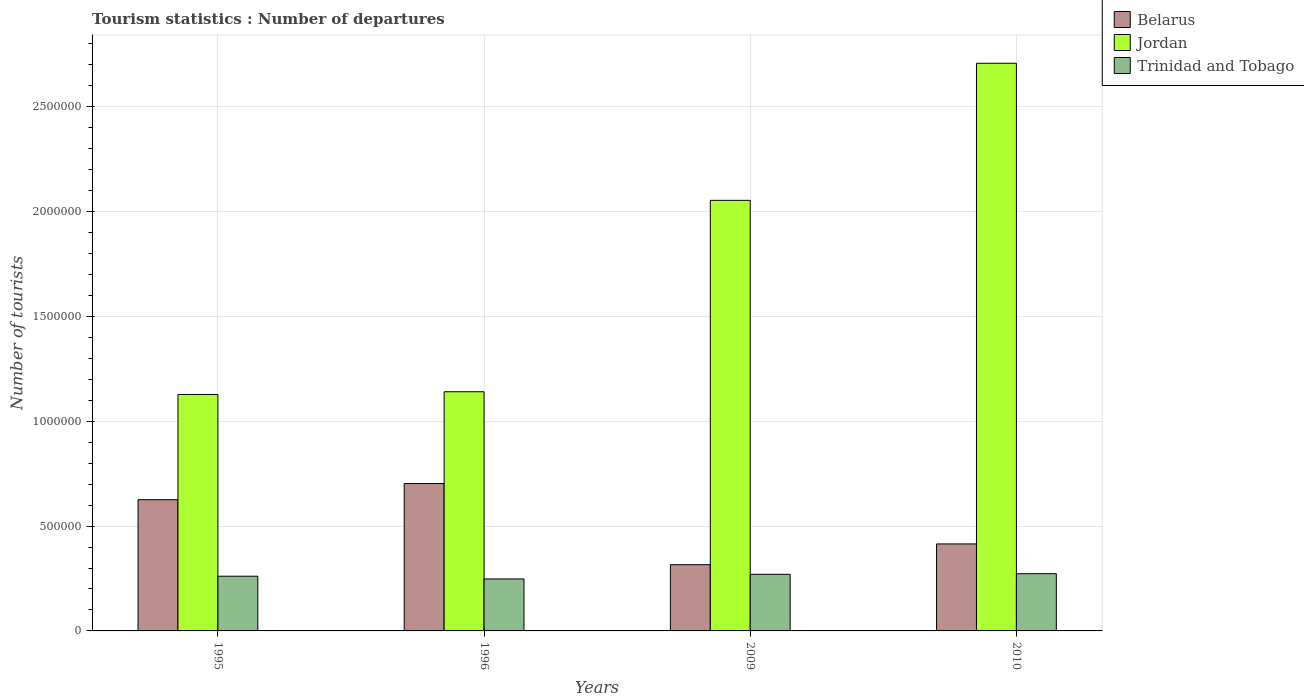Are the number of bars per tick equal to the number of legend labels?
Make the answer very short. Yes. Are the number of bars on each tick of the X-axis equal?
Provide a short and direct response. Yes. What is the number of tourist departures in Jordan in 1995?
Offer a terse response. 1.13e+06. Across all years, what is the maximum number of tourist departures in Belarus?
Your response must be concise. 7.03e+05. Across all years, what is the minimum number of tourist departures in Belarus?
Offer a very short reply. 3.16e+05. In which year was the number of tourist departures in Trinidad and Tobago maximum?
Provide a succinct answer. 2010. What is the total number of tourist departures in Trinidad and Tobago in the graph?
Your answer should be compact. 1.05e+06. What is the difference between the number of tourist departures in Belarus in 1996 and that in 2009?
Your answer should be compact. 3.87e+05. What is the difference between the number of tourist departures in Belarus in 2010 and the number of tourist departures in Jordan in 1995?
Provide a short and direct response. -7.13e+05. What is the average number of tourist departures in Trinidad and Tobago per year?
Your answer should be compact. 2.63e+05. In the year 2009, what is the difference between the number of tourist departures in Trinidad and Tobago and number of tourist departures in Jordan?
Your answer should be compact. -1.78e+06. What is the ratio of the number of tourist departures in Belarus in 1995 to that in 2010?
Ensure brevity in your answer.  1.51. Is the number of tourist departures in Jordan in 1996 less than that in 2009?
Your answer should be compact. Yes. What is the difference between the highest and the second highest number of tourist departures in Belarus?
Your answer should be very brief. 7.70e+04. What is the difference between the highest and the lowest number of tourist departures in Jordan?
Your answer should be compact. 1.58e+06. What does the 1st bar from the left in 1995 represents?
Offer a terse response. Belarus. What does the 3rd bar from the right in 2010 represents?
Provide a short and direct response. Belarus. Are all the bars in the graph horizontal?
Give a very brief answer. No. Does the graph contain any zero values?
Offer a terse response. No. Where does the legend appear in the graph?
Keep it short and to the point. Top right. How many legend labels are there?
Offer a terse response. 3. How are the legend labels stacked?
Provide a short and direct response. Vertical. What is the title of the graph?
Give a very brief answer. Tourism statistics : Number of departures. Does "American Samoa" appear as one of the legend labels in the graph?
Your answer should be compact. No. What is the label or title of the Y-axis?
Your answer should be compact. Number of tourists. What is the Number of tourists in Belarus in 1995?
Offer a terse response. 6.26e+05. What is the Number of tourists of Jordan in 1995?
Make the answer very short. 1.13e+06. What is the Number of tourists of Trinidad and Tobago in 1995?
Provide a short and direct response. 2.61e+05. What is the Number of tourists in Belarus in 1996?
Provide a succinct answer. 7.03e+05. What is the Number of tourists of Jordan in 1996?
Make the answer very short. 1.14e+06. What is the Number of tourists in Trinidad and Tobago in 1996?
Ensure brevity in your answer.  2.48e+05. What is the Number of tourists in Belarus in 2009?
Your response must be concise. 3.16e+05. What is the Number of tourists in Jordan in 2009?
Your response must be concise. 2.05e+06. What is the Number of tourists of Belarus in 2010?
Your answer should be very brief. 4.15e+05. What is the Number of tourists of Jordan in 2010?
Offer a terse response. 2.71e+06. What is the Number of tourists of Trinidad and Tobago in 2010?
Your answer should be compact. 2.73e+05. Across all years, what is the maximum Number of tourists in Belarus?
Ensure brevity in your answer.  7.03e+05. Across all years, what is the maximum Number of tourists of Jordan?
Your answer should be compact. 2.71e+06. Across all years, what is the maximum Number of tourists of Trinidad and Tobago?
Keep it short and to the point. 2.73e+05. Across all years, what is the minimum Number of tourists of Belarus?
Provide a succinct answer. 3.16e+05. Across all years, what is the minimum Number of tourists of Jordan?
Make the answer very short. 1.13e+06. Across all years, what is the minimum Number of tourists in Trinidad and Tobago?
Provide a short and direct response. 2.48e+05. What is the total Number of tourists of Belarus in the graph?
Provide a short and direct response. 2.06e+06. What is the total Number of tourists in Jordan in the graph?
Ensure brevity in your answer.  7.03e+06. What is the total Number of tourists in Trinidad and Tobago in the graph?
Offer a very short reply. 1.05e+06. What is the difference between the Number of tourists in Belarus in 1995 and that in 1996?
Offer a terse response. -7.70e+04. What is the difference between the Number of tourists of Jordan in 1995 and that in 1996?
Keep it short and to the point. -1.30e+04. What is the difference between the Number of tourists in Trinidad and Tobago in 1995 and that in 1996?
Offer a very short reply. 1.30e+04. What is the difference between the Number of tourists of Belarus in 1995 and that in 2009?
Your response must be concise. 3.10e+05. What is the difference between the Number of tourists in Jordan in 1995 and that in 2009?
Your answer should be very brief. -9.26e+05. What is the difference between the Number of tourists of Trinidad and Tobago in 1995 and that in 2009?
Offer a terse response. -9000. What is the difference between the Number of tourists in Belarus in 1995 and that in 2010?
Your response must be concise. 2.11e+05. What is the difference between the Number of tourists of Jordan in 1995 and that in 2010?
Give a very brief answer. -1.58e+06. What is the difference between the Number of tourists of Trinidad and Tobago in 1995 and that in 2010?
Make the answer very short. -1.20e+04. What is the difference between the Number of tourists in Belarus in 1996 and that in 2009?
Your response must be concise. 3.87e+05. What is the difference between the Number of tourists of Jordan in 1996 and that in 2009?
Your response must be concise. -9.13e+05. What is the difference between the Number of tourists in Trinidad and Tobago in 1996 and that in 2009?
Offer a terse response. -2.20e+04. What is the difference between the Number of tourists in Belarus in 1996 and that in 2010?
Your response must be concise. 2.88e+05. What is the difference between the Number of tourists of Jordan in 1996 and that in 2010?
Offer a very short reply. -1.57e+06. What is the difference between the Number of tourists in Trinidad and Tobago in 1996 and that in 2010?
Offer a very short reply. -2.50e+04. What is the difference between the Number of tourists of Belarus in 2009 and that in 2010?
Your answer should be compact. -9.90e+04. What is the difference between the Number of tourists of Jordan in 2009 and that in 2010?
Your answer should be compact. -6.54e+05. What is the difference between the Number of tourists in Trinidad and Tobago in 2009 and that in 2010?
Your answer should be very brief. -3000. What is the difference between the Number of tourists in Belarus in 1995 and the Number of tourists in Jordan in 1996?
Your answer should be very brief. -5.15e+05. What is the difference between the Number of tourists of Belarus in 1995 and the Number of tourists of Trinidad and Tobago in 1996?
Offer a very short reply. 3.78e+05. What is the difference between the Number of tourists in Jordan in 1995 and the Number of tourists in Trinidad and Tobago in 1996?
Offer a very short reply. 8.80e+05. What is the difference between the Number of tourists in Belarus in 1995 and the Number of tourists in Jordan in 2009?
Your response must be concise. -1.43e+06. What is the difference between the Number of tourists of Belarus in 1995 and the Number of tourists of Trinidad and Tobago in 2009?
Provide a succinct answer. 3.56e+05. What is the difference between the Number of tourists in Jordan in 1995 and the Number of tourists in Trinidad and Tobago in 2009?
Provide a short and direct response. 8.58e+05. What is the difference between the Number of tourists of Belarus in 1995 and the Number of tourists of Jordan in 2010?
Make the answer very short. -2.08e+06. What is the difference between the Number of tourists of Belarus in 1995 and the Number of tourists of Trinidad and Tobago in 2010?
Your response must be concise. 3.53e+05. What is the difference between the Number of tourists in Jordan in 1995 and the Number of tourists in Trinidad and Tobago in 2010?
Provide a short and direct response. 8.55e+05. What is the difference between the Number of tourists of Belarus in 1996 and the Number of tourists of Jordan in 2009?
Your answer should be very brief. -1.35e+06. What is the difference between the Number of tourists of Belarus in 1996 and the Number of tourists of Trinidad and Tobago in 2009?
Give a very brief answer. 4.33e+05. What is the difference between the Number of tourists of Jordan in 1996 and the Number of tourists of Trinidad and Tobago in 2009?
Your answer should be compact. 8.71e+05. What is the difference between the Number of tourists in Belarus in 1996 and the Number of tourists in Jordan in 2010?
Offer a very short reply. -2.00e+06. What is the difference between the Number of tourists in Belarus in 1996 and the Number of tourists in Trinidad and Tobago in 2010?
Your answer should be very brief. 4.30e+05. What is the difference between the Number of tourists in Jordan in 1996 and the Number of tourists in Trinidad and Tobago in 2010?
Your answer should be very brief. 8.68e+05. What is the difference between the Number of tourists in Belarus in 2009 and the Number of tourists in Jordan in 2010?
Your response must be concise. -2.39e+06. What is the difference between the Number of tourists in Belarus in 2009 and the Number of tourists in Trinidad and Tobago in 2010?
Offer a terse response. 4.30e+04. What is the difference between the Number of tourists in Jordan in 2009 and the Number of tourists in Trinidad and Tobago in 2010?
Make the answer very short. 1.78e+06. What is the average Number of tourists in Belarus per year?
Provide a short and direct response. 5.15e+05. What is the average Number of tourists of Jordan per year?
Your answer should be very brief. 1.76e+06. What is the average Number of tourists of Trinidad and Tobago per year?
Your answer should be compact. 2.63e+05. In the year 1995, what is the difference between the Number of tourists of Belarus and Number of tourists of Jordan?
Your answer should be compact. -5.02e+05. In the year 1995, what is the difference between the Number of tourists of Belarus and Number of tourists of Trinidad and Tobago?
Your answer should be compact. 3.65e+05. In the year 1995, what is the difference between the Number of tourists of Jordan and Number of tourists of Trinidad and Tobago?
Your answer should be very brief. 8.67e+05. In the year 1996, what is the difference between the Number of tourists in Belarus and Number of tourists in Jordan?
Provide a short and direct response. -4.38e+05. In the year 1996, what is the difference between the Number of tourists in Belarus and Number of tourists in Trinidad and Tobago?
Keep it short and to the point. 4.55e+05. In the year 1996, what is the difference between the Number of tourists of Jordan and Number of tourists of Trinidad and Tobago?
Give a very brief answer. 8.93e+05. In the year 2009, what is the difference between the Number of tourists of Belarus and Number of tourists of Jordan?
Provide a short and direct response. -1.74e+06. In the year 2009, what is the difference between the Number of tourists in Belarus and Number of tourists in Trinidad and Tobago?
Ensure brevity in your answer.  4.60e+04. In the year 2009, what is the difference between the Number of tourists in Jordan and Number of tourists in Trinidad and Tobago?
Your answer should be very brief. 1.78e+06. In the year 2010, what is the difference between the Number of tourists in Belarus and Number of tourists in Jordan?
Offer a terse response. -2.29e+06. In the year 2010, what is the difference between the Number of tourists in Belarus and Number of tourists in Trinidad and Tobago?
Offer a terse response. 1.42e+05. In the year 2010, what is the difference between the Number of tourists of Jordan and Number of tourists of Trinidad and Tobago?
Provide a short and direct response. 2.44e+06. What is the ratio of the Number of tourists in Belarus in 1995 to that in 1996?
Give a very brief answer. 0.89. What is the ratio of the Number of tourists of Trinidad and Tobago in 1995 to that in 1996?
Your answer should be compact. 1.05. What is the ratio of the Number of tourists in Belarus in 1995 to that in 2009?
Your response must be concise. 1.98. What is the ratio of the Number of tourists in Jordan in 1995 to that in 2009?
Offer a terse response. 0.55. What is the ratio of the Number of tourists in Trinidad and Tobago in 1995 to that in 2009?
Your answer should be very brief. 0.97. What is the ratio of the Number of tourists in Belarus in 1995 to that in 2010?
Your answer should be compact. 1.51. What is the ratio of the Number of tourists of Jordan in 1995 to that in 2010?
Offer a very short reply. 0.42. What is the ratio of the Number of tourists of Trinidad and Tobago in 1995 to that in 2010?
Provide a short and direct response. 0.96. What is the ratio of the Number of tourists of Belarus in 1996 to that in 2009?
Make the answer very short. 2.22. What is the ratio of the Number of tourists of Jordan in 1996 to that in 2009?
Make the answer very short. 0.56. What is the ratio of the Number of tourists of Trinidad and Tobago in 1996 to that in 2009?
Keep it short and to the point. 0.92. What is the ratio of the Number of tourists in Belarus in 1996 to that in 2010?
Your answer should be compact. 1.69. What is the ratio of the Number of tourists in Jordan in 1996 to that in 2010?
Keep it short and to the point. 0.42. What is the ratio of the Number of tourists of Trinidad and Tobago in 1996 to that in 2010?
Your answer should be very brief. 0.91. What is the ratio of the Number of tourists in Belarus in 2009 to that in 2010?
Make the answer very short. 0.76. What is the ratio of the Number of tourists of Jordan in 2009 to that in 2010?
Make the answer very short. 0.76. What is the difference between the highest and the second highest Number of tourists of Belarus?
Your answer should be compact. 7.70e+04. What is the difference between the highest and the second highest Number of tourists of Jordan?
Ensure brevity in your answer.  6.54e+05. What is the difference between the highest and the second highest Number of tourists in Trinidad and Tobago?
Offer a terse response. 3000. What is the difference between the highest and the lowest Number of tourists in Belarus?
Provide a succinct answer. 3.87e+05. What is the difference between the highest and the lowest Number of tourists of Jordan?
Provide a short and direct response. 1.58e+06. What is the difference between the highest and the lowest Number of tourists in Trinidad and Tobago?
Keep it short and to the point. 2.50e+04. 